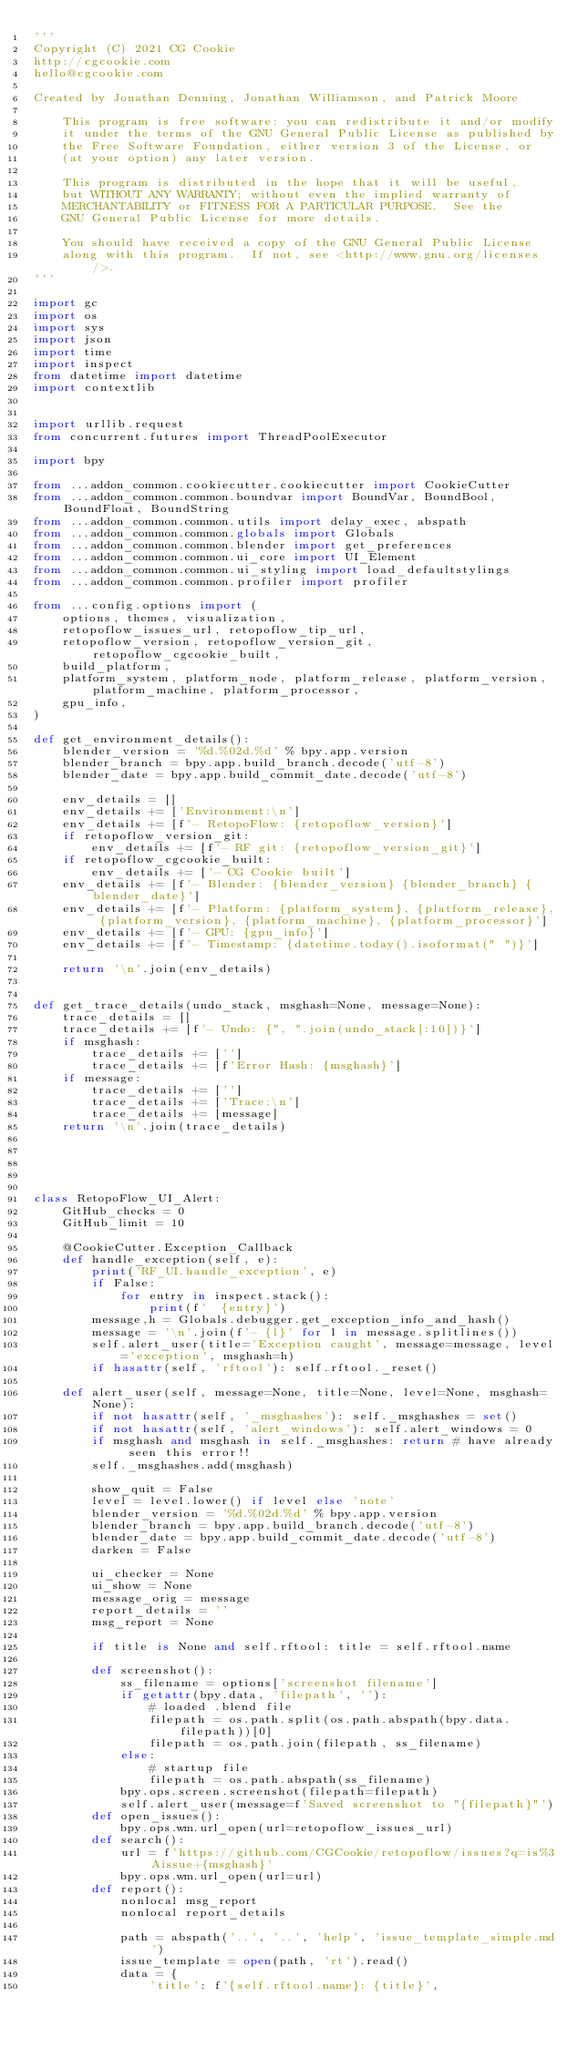<code> <loc_0><loc_0><loc_500><loc_500><_Python_>'''
Copyright (C) 2021 CG Cookie
http://cgcookie.com
hello@cgcookie.com

Created by Jonathan Denning, Jonathan Williamson, and Patrick Moore

    This program is free software: you can redistribute it and/or modify
    it under the terms of the GNU General Public License as published by
    the Free Software Foundation, either version 3 of the License, or
    (at your option) any later version.

    This program is distributed in the hope that it will be useful,
    but WITHOUT ANY WARRANTY; without even the implied warranty of
    MERCHANTABILITY or FITNESS FOR A PARTICULAR PURPOSE.  See the
    GNU General Public License for more details.

    You should have received a copy of the GNU General Public License
    along with this program.  If not, see <http://www.gnu.org/licenses/>.
'''

import gc
import os
import sys
import json
import time
import inspect
from datetime import datetime
import contextlib


import urllib.request
from concurrent.futures import ThreadPoolExecutor

import bpy

from ...addon_common.cookiecutter.cookiecutter import CookieCutter
from ...addon_common.common.boundvar import BoundVar, BoundBool, BoundFloat, BoundString
from ...addon_common.common.utils import delay_exec, abspath
from ...addon_common.common.globals import Globals
from ...addon_common.common.blender import get_preferences
from ...addon_common.common.ui_core import UI_Element
from ...addon_common.common.ui_styling import load_defaultstylings
from ...addon_common.common.profiler import profiler

from ...config.options import (
    options, themes, visualization,
    retopoflow_issues_url, retopoflow_tip_url,
    retopoflow_version, retopoflow_version_git, retopoflow_cgcookie_built,
    build_platform,
    platform_system, platform_node, platform_release, platform_version, platform_machine, platform_processor,
    gpu_info,
)

def get_environment_details():
    blender_version = '%d.%02d.%d' % bpy.app.version
    blender_branch = bpy.app.build_branch.decode('utf-8')
    blender_date = bpy.app.build_commit_date.decode('utf-8')

    env_details = []
    env_details += ['Environment:\n']
    env_details += [f'- RetopoFlow: {retopoflow_version}']
    if retopoflow_version_git:
        env_details += [f'- RF git: {retopoflow_version_git}']
    if retopoflow_cgcookie_built:
        env_details += ['- CG Cookie built']
    env_details += [f'- Blender: {blender_version} {blender_branch} {blender_date}']
    env_details += [f'- Platform: {platform_system}, {platform_release}, {platform_version}, {platform_machine}, {platform_processor}']
    env_details += [f'- GPU: {gpu_info}']
    env_details += [f'- Timestamp: {datetime.today().isoformat(" ")}']

    return '\n'.join(env_details)


def get_trace_details(undo_stack, msghash=None, message=None):
    trace_details = []
    trace_details += [f'- Undo: {", ".join(undo_stack[:10])}']
    if msghash:
        trace_details += ['']
        trace_details += [f'Error Hash: {msghash}']
    if message:
        trace_details += ['']
        trace_details += ['Trace:\n']
        trace_details += [message]
    return '\n'.join(trace_details)





class RetopoFlow_UI_Alert:
    GitHub_checks = 0
    GitHub_limit = 10

    @CookieCutter.Exception_Callback
    def handle_exception(self, e):
        print('RF_UI.handle_exception', e)
        if False:
            for entry in inspect.stack():
                print(f'  {entry}')
        message,h = Globals.debugger.get_exception_info_and_hash()
        message = '\n'.join(f'- {l}' for l in message.splitlines())
        self.alert_user(title='Exception caught', message=message, level='exception', msghash=h)
        if hasattr(self, 'rftool'): self.rftool._reset()

    def alert_user(self, message=None, title=None, level=None, msghash=None):
        if not hasattr(self, '_msghashes'): self._msghashes = set()
        if not hasattr(self, 'alert_windows'): self.alert_windows = 0
        if msghash and msghash in self._msghashes: return # have already seen this error!!
        self._msghashes.add(msghash)

        show_quit = False
        level = level.lower() if level else 'note'
        blender_version = '%d.%02d.%d' % bpy.app.version
        blender_branch = bpy.app.build_branch.decode('utf-8')
        blender_date = bpy.app.build_commit_date.decode('utf-8')
        darken = False

        ui_checker = None
        ui_show = None
        message_orig = message
        report_details = ''
        msg_report = None

        if title is None and self.rftool: title = self.rftool.name

        def screenshot():
            ss_filename = options['screenshot filename']
            if getattr(bpy.data, 'filepath', ''):
                # loaded .blend file
                filepath = os.path.split(os.path.abspath(bpy.data.filepath))[0]
                filepath = os.path.join(filepath, ss_filename)
            else:
                # startup file
                filepath = os.path.abspath(ss_filename)
            bpy.ops.screen.screenshot(filepath=filepath)
            self.alert_user(message=f'Saved screenshot to "{filepath}"')
        def open_issues():
            bpy.ops.wm.url_open(url=retopoflow_issues_url)
        def search():
            url = f'https://github.com/CGCookie/retopoflow/issues?q=is%3Aissue+{msghash}'
            bpy.ops.wm.url_open(url=url)
        def report():
            nonlocal msg_report
            nonlocal report_details

            path = abspath('..', '..', 'help', 'issue_template_simple.md')
            issue_template = open(path, 'rt').read()
            data = {
                'title': f'{self.rftool.name}: {title}',</code> 